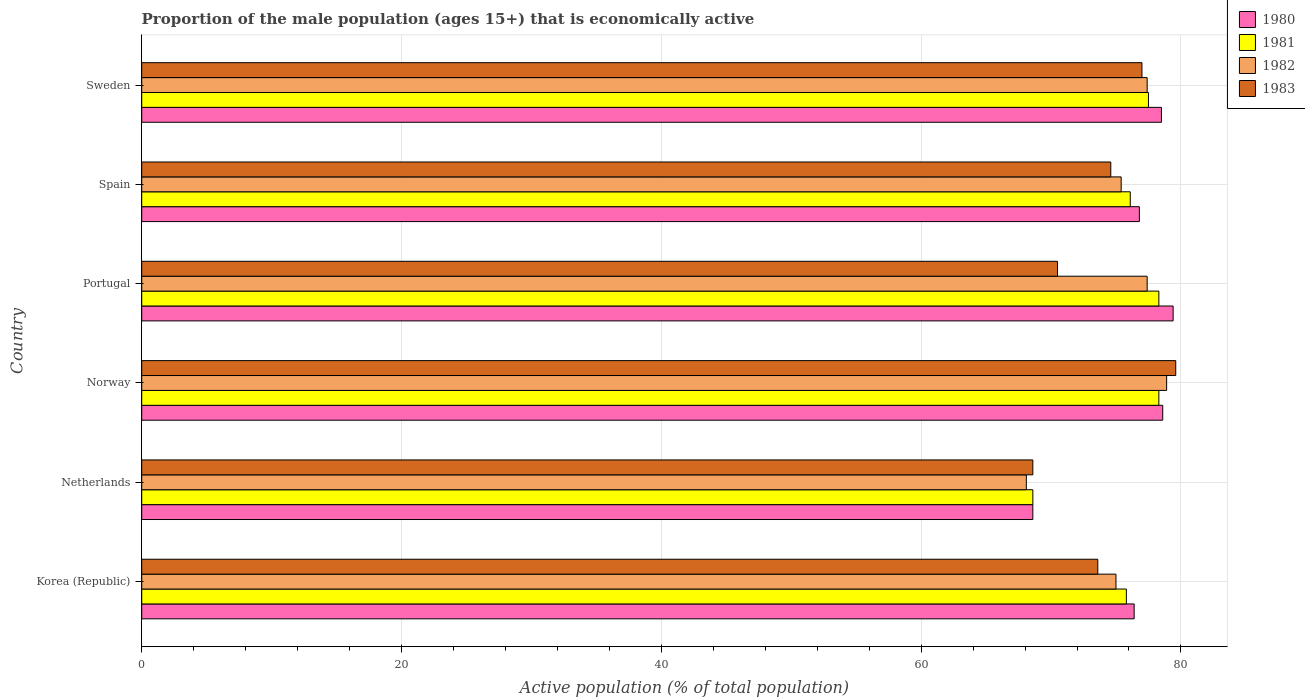Are the number of bars per tick equal to the number of legend labels?
Make the answer very short. Yes. Are the number of bars on each tick of the Y-axis equal?
Offer a terse response. Yes. How many bars are there on the 4th tick from the top?
Give a very brief answer. 4. What is the label of the 4th group of bars from the top?
Your answer should be very brief. Norway. In how many cases, is the number of bars for a given country not equal to the number of legend labels?
Ensure brevity in your answer.  0. What is the proportion of the male population that is economically active in 1981 in Korea (Republic)?
Your answer should be very brief. 75.8. Across all countries, what is the maximum proportion of the male population that is economically active in 1981?
Provide a short and direct response. 78.3. Across all countries, what is the minimum proportion of the male population that is economically active in 1982?
Provide a succinct answer. 68.1. In which country was the proportion of the male population that is economically active in 1983 maximum?
Your response must be concise. Norway. In which country was the proportion of the male population that is economically active in 1981 minimum?
Provide a short and direct response. Netherlands. What is the total proportion of the male population that is economically active in 1983 in the graph?
Your answer should be compact. 443.9. What is the average proportion of the male population that is economically active in 1981 per country?
Your answer should be very brief. 75.77. What is the difference between the proportion of the male population that is economically active in 1980 and proportion of the male population that is economically active in 1983 in Norway?
Give a very brief answer. -1. What is the ratio of the proportion of the male population that is economically active in 1980 in Netherlands to that in Sweden?
Your response must be concise. 0.87. What is the difference between the highest and the second highest proportion of the male population that is economically active in 1982?
Provide a succinct answer. 1.5. What is the difference between the highest and the lowest proportion of the male population that is economically active in 1982?
Ensure brevity in your answer.  10.8. In how many countries, is the proportion of the male population that is economically active in 1981 greater than the average proportion of the male population that is economically active in 1981 taken over all countries?
Give a very brief answer. 5. What does the 3rd bar from the top in Portugal represents?
Your answer should be compact. 1981. How many bars are there?
Provide a short and direct response. 24. How many countries are there in the graph?
Your answer should be compact. 6. What is the difference between two consecutive major ticks on the X-axis?
Your response must be concise. 20. Are the values on the major ticks of X-axis written in scientific E-notation?
Offer a terse response. No. Where does the legend appear in the graph?
Provide a short and direct response. Top right. How many legend labels are there?
Offer a terse response. 4. What is the title of the graph?
Ensure brevity in your answer.  Proportion of the male population (ages 15+) that is economically active. Does "1994" appear as one of the legend labels in the graph?
Make the answer very short. No. What is the label or title of the X-axis?
Ensure brevity in your answer.  Active population (% of total population). What is the Active population (% of total population) in 1980 in Korea (Republic)?
Your answer should be compact. 76.4. What is the Active population (% of total population) in 1981 in Korea (Republic)?
Ensure brevity in your answer.  75.8. What is the Active population (% of total population) in 1982 in Korea (Republic)?
Your answer should be compact. 75. What is the Active population (% of total population) of 1983 in Korea (Republic)?
Provide a succinct answer. 73.6. What is the Active population (% of total population) of 1980 in Netherlands?
Offer a terse response. 68.6. What is the Active population (% of total population) in 1981 in Netherlands?
Provide a succinct answer. 68.6. What is the Active population (% of total population) in 1982 in Netherlands?
Keep it short and to the point. 68.1. What is the Active population (% of total population) of 1983 in Netherlands?
Make the answer very short. 68.6. What is the Active population (% of total population) of 1980 in Norway?
Give a very brief answer. 78.6. What is the Active population (% of total population) of 1981 in Norway?
Ensure brevity in your answer.  78.3. What is the Active population (% of total population) of 1982 in Norway?
Your answer should be compact. 78.9. What is the Active population (% of total population) in 1983 in Norway?
Your answer should be very brief. 79.6. What is the Active population (% of total population) in 1980 in Portugal?
Offer a terse response. 79.4. What is the Active population (% of total population) in 1981 in Portugal?
Your response must be concise. 78.3. What is the Active population (% of total population) of 1982 in Portugal?
Offer a very short reply. 77.4. What is the Active population (% of total population) of 1983 in Portugal?
Keep it short and to the point. 70.5. What is the Active population (% of total population) of 1980 in Spain?
Offer a terse response. 76.8. What is the Active population (% of total population) of 1981 in Spain?
Your answer should be very brief. 76.1. What is the Active population (% of total population) in 1982 in Spain?
Your answer should be compact. 75.4. What is the Active population (% of total population) in 1983 in Spain?
Your response must be concise. 74.6. What is the Active population (% of total population) of 1980 in Sweden?
Your answer should be compact. 78.5. What is the Active population (% of total population) in 1981 in Sweden?
Your answer should be very brief. 77.5. What is the Active population (% of total population) of 1982 in Sweden?
Your response must be concise. 77.4. Across all countries, what is the maximum Active population (% of total population) of 1980?
Provide a short and direct response. 79.4. Across all countries, what is the maximum Active population (% of total population) of 1981?
Provide a short and direct response. 78.3. Across all countries, what is the maximum Active population (% of total population) in 1982?
Offer a very short reply. 78.9. Across all countries, what is the maximum Active population (% of total population) of 1983?
Your answer should be compact. 79.6. Across all countries, what is the minimum Active population (% of total population) of 1980?
Your answer should be very brief. 68.6. Across all countries, what is the minimum Active population (% of total population) in 1981?
Offer a very short reply. 68.6. Across all countries, what is the minimum Active population (% of total population) in 1982?
Offer a very short reply. 68.1. Across all countries, what is the minimum Active population (% of total population) of 1983?
Provide a succinct answer. 68.6. What is the total Active population (% of total population) of 1980 in the graph?
Ensure brevity in your answer.  458.3. What is the total Active population (% of total population) of 1981 in the graph?
Offer a very short reply. 454.6. What is the total Active population (% of total population) of 1982 in the graph?
Offer a very short reply. 452.2. What is the total Active population (% of total population) in 1983 in the graph?
Your answer should be compact. 443.9. What is the difference between the Active population (% of total population) in 1980 in Korea (Republic) and that in Netherlands?
Provide a succinct answer. 7.8. What is the difference between the Active population (% of total population) of 1981 in Korea (Republic) and that in Netherlands?
Offer a very short reply. 7.2. What is the difference between the Active population (% of total population) in 1983 in Korea (Republic) and that in Netherlands?
Ensure brevity in your answer.  5. What is the difference between the Active population (% of total population) in 1980 in Korea (Republic) and that in Norway?
Offer a terse response. -2.2. What is the difference between the Active population (% of total population) of 1981 in Korea (Republic) and that in Norway?
Your answer should be compact. -2.5. What is the difference between the Active population (% of total population) in 1982 in Korea (Republic) and that in Norway?
Ensure brevity in your answer.  -3.9. What is the difference between the Active population (% of total population) of 1980 in Korea (Republic) and that in Spain?
Your response must be concise. -0.4. What is the difference between the Active population (% of total population) of 1981 in Korea (Republic) and that in Spain?
Your response must be concise. -0.3. What is the difference between the Active population (% of total population) of 1983 in Korea (Republic) and that in Spain?
Your answer should be compact. -1. What is the difference between the Active population (% of total population) in 1980 in Korea (Republic) and that in Sweden?
Give a very brief answer. -2.1. What is the difference between the Active population (% of total population) in 1980 in Netherlands and that in Norway?
Your answer should be very brief. -10. What is the difference between the Active population (% of total population) in 1981 in Netherlands and that in Norway?
Make the answer very short. -9.7. What is the difference between the Active population (% of total population) of 1982 in Netherlands and that in Norway?
Provide a succinct answer. -10.8. What is the difference between the Active population (% of total population) in 1983 in Netherlands and that in Norway?
Offer a very short reply. -11. What is the difference between the Active population (% of total population) of 1980 in Netherlands and that in Portugal?
Your response must be concise. -10.8. What is the difference between the Active population (% of total population) in 1981 in Netherlands and that in Portugal?
Provide a succinct answer. -9.7. What is the difference between the Active population (% of total population) of 1980 in Netherlands and that in Spain?
Ensure brevity in your answer.  -8.2. What is the difference between the Active population (% of total population) of 1981 in Netherlands and that in Spain?
Offer a terse response. -7.5. What is the difference between the Active population (% of total population) of 1982 in Netherlands and that in Spain?
Your answer should be compact. -7.3. What is the difference between the Active population (% of total population) of 1980 in Netherlands and that in Sweden?
Give a very brief answer. -9.9. What is the difference between the Active population (% of total population) of 1982 in Netherlands and that in Sweden?
Offer a very short reply. -9.3. What is the difference between the Active population (% of total population) in 1983 in Netherlands and that in Sweden?
Ensure brevity in your answer.  -8.4. What is the difference between the Active population (% of total population) in 1980 in Norway and that in Portugal?
Your answer should be compact. -0.8. What is the difference between the Active population (% of total population) in 1981 in Norway and that in Portugal?
Provide a short and direct response. 0. What is the difference between the Active population (% of total population) in 1982 in Norway and that in Portugal?
Your response must be concise. 1.5. What is the difference between the Active population (% of total population) in 1980 in Norway and that in Spain?
Make the answer very short. 1.8. What is the difference between the Active population (% of total population) in 1981 in Norway and that in Spain?
Keep it short and to the point. 2.2. What is the difference between the Active population (% of total population) of 1982 in Norway and that in Spain?
Your response must be concise. 3.5. What is the difference between the Active population (% of total population) in 1983 in Norway and that in Spain?
Make the answer very short. 5. What is the difference between the Active population (% of total population) in 1982 in Norway and that in Sweden?
Offer a terse response. 1.5. What is the difference between the Active population (% of total population) in 1980 in Portugal and that in Spain?
Your answer should be very brief. 2.6. What is the difference between the Active population (% of total population) of 1982 in Portugal and that in Spain?
Make the answer very short. 2. What is the difference between the Active population (% of total population) in 1981 in Portugal and that in Sweden?
Make the answer very short. 0.8. What is the difference between the Active population (% of total population) in 1982 in Portugal and that in Sweden?
Provide a succinct answer. 0. What is the difference between the Active population (% of total population) in 1983 in Portugal and that in Sweden?
Your answer should be very brief. -6.5. What is the difference between the Active population (% of total population) of 1981 in Spain and that in Sweden?
Your answer should be very brief. -1.4. What is the difference between the Active population (% of total population) in 1982 in Spain and that in Sweden?
Give a very brief answer. -2. What is the difference between the Active population (% of total population) of 1983 in Spain and that in Sweden?
Your answer should be very brief. -2.4. What is the difference between the Active population (% of total population) in 1981 in Korea (Republic) and the Active population (% of total population) in 1982 in Netherlands?
Your answer should be compact. 7.7. What is the difference between the Active population (% of total population) of 1980 in Korea (Republic) and the Active population (% of total population) of 1981 in Norway?
Ensure brevity in your answer.  -1.9. What is the difference between the Active population (% of total population) of 1981 in Korea (Republic) and the Active population (% of total population) of 1982 in Norway?
Provide a short and direct response. -3.1. What is the difference between the Active population (% of total population) in 1981 in Korea (Republic) and the Active population (% of total population) in 1982 in Portugal?
Make the answer very short. -1.6. What is the difference between the Active population (% of total population) in 1980 in Korea (Republic) and the Active population (% of total population) in 1982 in Spain?
Your response must be concise. 1. What is the difference between the Active population (% of total population) in 1982 in Korea (Republic) and the Active population (% of total population) in 1983 in Spain?
Provide a succinct answer. 0.4. What is the difference between the Active population (% of total population) in 1980 in Korea (Republic) and the Active population (% of total population) in 1981 in Sweden?
Your answer should be compact. -1.1. What is the difference between the Active population (% of total population) in 1981 in Korea (Republic) and the Active population (% of total population) in 1982 in Sweden?
Give a very brief answer. -1.6. What is the difference between the Active population (% of total population) in 1981 in Korea (Republic) and the Active population (% of total population) in 1983 in Sweden?
Offer a terse response. -1.2. What is the difference between the Active population (% of total population) of 1980 in Netherlands and the Active population (% of total population) of 1981 in Norway?
Ensure brevity in your answer.  -9.7. What is the difference between the Active population (% of total population) in 1980 in Netherlands and the Active population (% of total population) in 1982 in Norway?
Make the answer very short. -10.3. What is the difference between the Active population (% of total population) of 1980 in Netherlands and the Active population (% of total population) of 1983 in Norway?
Provide a short and direct response. -11. What is the difference between the Active population (% of total population) in 1981 in Netherlands and the Active population (% of total population) in 1983 in Norway?
Keep it short and to the point. -11. What is the difference between the Active population (% of total population) of 1982 in Netherlands and the Active population (% of total population) of 1983 in Norway?
Give a very brief answer. -11.5. What is the difference between the Active population (% of total population) in 1980 in Netherlands and the Active population (% of total population) in 1982 in Portugal?
Offer a very short reply. -8.8. What is the difference between the Active population (% of total population) of 1980 in Netherlands and the Active population (% of total population) of 1983 in Portugal?
Give a very brief answer. -1.9. What is the difference between the Active population (% of total population) of 1982 in Netherlands and the Active population (% of total population) of 1983 in Portugal?
Ensure brevity in your answer.  -2.4. What is the difference between the Active population (% of total population) of 1980 in Netherlands and the Active population (% of total population) of 1982 in Spain?
Provide a short and direct response. -6.8. What is the difference between the Active population (% of total population) in 1981 in Netherlands and the Active population (% of total population) in 1983 in Spain?
Give a very brief answer. -6. What is the difference between the Active population (% of total population) in 1982 in Netherlands and the Active population (% of total population) in 1983 in Spain?
Make the answer very short. -6.5. What is the difference between the Active population (% of total population) of 1981 in Netherlands and the Active population (% of total population) of 1982 in Sweden?
Ensure brevity in your answer.  -8.8. What is the difference between the Active population (% of total population) in 1981 in Netherlands and the Active population (% of total population) in 1983 in Sweden?
Offer a terse response. -8.4. What is the difference between the Active population (% of total population) in 1982 in Norway and the Active population (% of total population) in 1983 in Portugal?
Make the answer very short. 8.4. What is the difference between the Active population (% of total population) in 1980 in Norway and the Active population (% of total population) in 1981 in Spain?
Provide a succinct answer. 2.5. What is the difference between the Active population (% of total population) of 1980 in Norway and the Active population (% of total population) of 1983 in Spain?
Provide a succinct answer. 4. What is the difference between the Active population (% of total population) of 1981 in Norway and the Active population (% of total population) of 1982 in Spain?
Ensure brevity in your answer.  2.9. What is the difference between the Active population (% of total population) in 1981 in Norway and the Active population (% of total population) in 1983 in Sweden?
Ensure brevity in your answer.  1.3. What is the difference between the Active population (% of total population) of 1980 in Portugal and the Active population (% of total population) of 1981 in Spain?
Keep it short and to the point. 3.3. What is the difference between the Active population (% of total population) of 1980 in Portugal and the Active population (% of total population) of 1983 in Spain?
Make the answer very short. 4.8. What is the difference between the Active population (% of total population) in 1981 in Portugal and the Active population (% of total population) in 1982 in Spain?
Provide a short and direct response. 2.9. What is the difference between the Active population (% of total population) in 1981 in Portugal and the Active population (% of total population) in 1983 in Spain?
Keep it short and to the point. 3.7. What is the difference between the Active population (% of total population) of 1982 in Portugal and the Active population (% of total population) of 1983 in Spain?
Ensure brevity in your answer.  2.8. What is the difference between the Active population (% of total population) of 1980 in Portugal and the Active population (% of total population) of 1981 in Sweden?
Keep it short and to the point. 1.9. What is the difference between the Active population (% of total population) of 1980 in Portugal and the Active population (% of total population) of 1982 in Sweden?
Provide a short and direct response. 2. What is the difference between the Active population (% of total population) in 1981 in Spain and the Active population (% of total population) in 1982 in Sweden?
Give a very brief answer. -1.3. What is the difference between the Active population (% of total population) in 1981 in Spain and the Active population (% of total population) in 1983 in Sweden?
Make the answer very short. -0.9. What is the difference between the Active population (% of total population) of 1982 in Spain and the Active population (% of total population) of 1983 in Sweden?
Make the answer very short. -1.6. What is the average Active population (% of total population) of 1980 per country?
Ensure brevity in your answer.  76.38. What is the average Active population (% of total population) of 1981 per country?
Your answer should be compact. 75.77. What is the average Active population (% of total population) in 1982 per country?
Your answer should be very brief. 75.37. What is the average Active population (% of total population) in 1983 per country?
Your response must be concise. 73.98. What is the difference between the Active population (% of total population) of 1980 and Active population (% of total population) of 1981 in Korea (Republic)?
Your answer should be compact. 0.6. What is the difference between the Active population (% of total population) in 1980 and Active population (% of total population) in 1982 in Korea (Republic)?
Your answer should be very brief. 1.4. What is the difference between the Active population (% of total population) in 1980 and Active population (% of total population) in 1983 in Korea (Republic)?
Provide a short and direct response. 2.8. What is the difference between the Active population (% of total population) of 1981 and Active population (% of total population) of 1983 in Korea (Republic)?
Ensure brevity in your answer.  2.2. What is the difference between the Active population (% of total population) of 1980 and Active population (% of total population) of 1981 in Netherlands?
Make the answer very short. 0. What is the difference between the Active population (% of total population) in 1980 and Active population (% of total population) in 1983 in Netherlands?
Ensure brevity in your answer.  0. What is the difference between the Active population (% of total population) of 1981 and Active population (% of total population) of 1983 in Netherlands?
Make the answer very short. 0. What is the difference between the Active population (% of total population) in 1980 and Active population (% of total population) in 1981 in Norway?
Keep it short and to the point. 0.3. What is the difference between the Active population (% of total population) in 1980 and Active population (% of total population) in 1983 in Norway?
Give a very brief answer. -1. What is the difference between the Active population (% of total population) in 1981 and Active population (% of total population) in 1982 in Norway?
Give a very brief answer. -0.6. What is the difference between the Active population (% of total population) of 1982 and Active population (% of total population) of 1983 in Norway?
Ensure brevity in your answer.  -0.7. What is the difference between the Active population (% of total population) of 1980 and Active population (% of total population) of 1982 in Portugal?
Give a very brief answer. 2. What is the difference between the Active population (% of total population) in 1981 and Active population (% of total population) in 1982 in Portugal?
Your answer should be compact. 0.9. What is the difference between the Active population (% of total population) in 1980 and Active population (% of total population) in 1983 in Spain?
Give a very brief answer. 2.2. What is the difference between the Active population (% of total population) in 1981 and Active population (% of total population) in 1982 in Spain?
Provide a short and direct response. 0.7. What is the difference between the Active population (% of total population) of 1982 and Active population (% of total population) of 1983 in Spain?
Provide a succinct answer. 0.8. What is the difference between the Active population (% of total population) in 1980 and Active population (% of total population) in 1981 in Sweden?
Provide a short and direct response. 1. What is the difference between the Active population (% of total population) in 1980 and Active population (% of total population) in 1982 in Sweden?
Give a very brief answer. 1.1. What is the difference between the Active population (% of total population) of 1982 and Active population (% of total population) of 1983 in Sweden?
Provide a short and direct response. 0.4. What is the ratio of the Active population (% of total population) in 1980 in Korea (Republic) to that in Netherlands?
Provide a short and direct response. 1.11. What is the ratio of the Active population (% of total population) in 1981 in Korea (Republic) to that in Netherlands?
Keep it short and to the point. 1.1. What is the ratio of the Active population (% of total population) in 1982 in Korea (Republic) to that in Netherlands?
Provide a succinct answer. 1.1. What is the ratio of the Active population (% of total population) of 1983 in Korea (Republic) to that in Netherlands?
Your answer should be compact. 1.07. What is the ratio of the Active population (% of total population) in 1981 in Korea (Republic) to that in Norway?
Provide a short and direct response. 0.97. What is the ratio of the Active population (% of total population) of 1982 in Korea (Republic) to that in Norway?
Keep it short and to the point. 0.95. What is the ratio of the Active population (% of total population) in 1983 in Korea (Republic) to that in Norway?
Give a very brief answer. 0.92. What is the ratio of the Active population (% of total population) in 1980 in Korea (Republic) to that in Portugal?
Give a very brief answer. 0.96. What is the ratio of the Active population (% of total population) of 1981 in Korea (Republic) to that in Portugal?
Offer a terse response. 0.97. What is the ratio of the Active population (% of total population) in 1982 in Korea (Republic) to that in Portugal?
Keep it short and to the point. 0.97. What is the ratio of the Active population (% of total population) of 1983 in Korea (Republic) to that in Portugal?
Give a very brief answer. 1.04. What is the ratio of the Active population (% of total population) of 1980 in Korea (Republic) to that in Spain?
Keep it short and to the point. 0.99. What is the ratio of the Active population (% of total population) in 1983 in Korea (Republic) to that in Spain?
Your response must be concise. 0.99. What is the ratio of the Active population (% of total population) in 1980 in Korea (Republic) to that in Sweden?
Offer a very short reply. 0.97. What is the ratio of the Active population (% of total population) of 1981 in Korea (Republic) to that in Sweden?
Provide a succinct answer. 0.98. What is the ratio of the Active population (% of total population) in 1983 in Korea (Republic) to that in Sweden?
Your response must be concise. 0.96. What is the ratio of the Active population (% of total population) in 1980 in Netherlands to that in Norway?
Your answer should be very brief. 0.87. What is the ratio of the Active population (% of total population) of 1981 in Netherlands to that in Norway?
Provide a succinct answer. 0.88. What is the ratio of the Active population (% of total population) of 1982 in Netherlands to that in Norway?
Give a very brief answer. 0.86. What is the ratio of the Active population (% of total population) in 1983 in Netherlands to that in Norway?
Your answer should be compact. 0.86. What is the ratio of the Active population (% of total population) of 1980 in Netherlands to that in Portugal?
Give a very brief answer. 0.86. What is the ratio of the Active population (% of total population) in 1981 in Netherlands to that in Portugal?
Provide a succinct answer. 0.88. What is the ratio of the Active population (% of total population) of 1982 in Netherlands to that in Portugal?
Your answer should be very brief. 0.88. What is the ratio of the Active population (% of total population) in 1983 in Netherlands to that in Portugal?
Offer a terse response. 0.97. What is the ratio of the Active population (% of total population) in 1980 in Netherlands to that in Spain?
Keep it short and to the point. 0.89. What is the ratio of the Active population (% of total population) in 1981 in Netherlands to that in Spain?
Provide a succinct answer. 0.9. What is the ratio of the Active population (% of total population) in 1982 in Netherlands to that in Spain?
Ensure brevity in your answer.  0.9. What is the ratio of the Active population (% of total population) in 1983 in Netherlands to that in Spain?
Make the answer very short. 0.92. What is the ratio of the Active population (% of total population) in 1980 in Netherlands to that in Sweden?
Your answer should be compact. 0.87. What is the ratio of the Active population (% of total population) in 1981 in Netherlands to that in Sweden?
Make the answer very short. 0.89. What is the ratio of the Active population (% of total population) of 1982 in Netherlands to that in Sweden?
Provide a succinct answer. 0.88. What is the ratio of the Active population (% of total population) of 1983 in Netherlands to that in Sweden?
Keep it short and to the point. 0.89. What is the ratio of the Active population (% of total population) of 1980 in Norway to that in Portugal?
Ensure brevity in your answer.  0.99. What is the ratio of the Active population (% of total population) in 1981 in Norway to that in Portugal?
Your answer should be very brief. 1. What is the ratio of the Active population (% of total population) of 1982 in Norway to that in Portugal?
Provide a short and direct response. 1.02. What is the ratio of the Active population (% of total population) of 1983 in Norway to that in Portugal?
Your response must be concise. 1.13. What is the ratio of the Active population (% of total population) of 1980 in Norway to that in Spain?
Offer a very short reply. 1.02. What is the ratio of the Active population (% of total population) in 1981 in Norway to that in Spain?
Make the answer very short. 1.03. What is the ratio of the Active population (% of total population) of 1982 in Norway to that in Spain?
Your answer should be compact. 1.05. What is the ratio of the Active population (% of total population) of 1983 in Norway to that in Spain?
Your answer should be compact. 1.07. What is the ratio of the Active population (% of total population) in 1980 in Norway to that in Sweden?
Make the answer very short. 1. What is the ratio of the Active population (% of total population) of 1981 in Norway to that in Sweden?
Your answer should be compact. 1.01. What is the ratio of the Active population (% of total population) in 1982 in Norway to that in Sweden?
Your answer should be very brief. 1.02. What is the ratio of the Active population (% of total population) in 1983 in Norway to that in Sweden?
Ensure brevity in your answer.  1.03. What is the ratio of the Active population (% of total population) of 1980 in Portugal to that in Spain?
Offer a terse response. 1.03. What is the ratio of the Active population (% of total population) in 1981 in Portugal to that in Spain?
Your response must be concise. 1.03. What is the ratio of the Active population (% of total population) of 1982 in Portugal to that in Spain?
Offer a very short reply. 1.03. What is the ratio of the Active population (% of total population) of 1983 in Portugal to that in Spain?
Provide a succinct answer. 0.94. What is the ratio of the Active population (% of total population) of 1980 in Portugal to that in Sweden?
Keep it short and to the point. 1.01. What is the ratio of the Active population (% of total population) of 1981 in Portugal to that in Sweden?
Give a very brief answer. 1.01. What is the ratio of the Active population (% of total population) of 1982 in Portugal to that in Sweden?
Your response must be concise. 1. What is the ratio of the Active population (% of total population) in 1983 in Portugal to that in Sweden?
Provide a short and direct response. 0.92. What is the ratio of the Active population (% of total population) in 1980 in Spain to that in Sweden?
Make the answer very short. 0.98. What is the ratio of the Active population (% of total population) in 1981 in Spain to that in Sweden?
Provide a succinct answer. 0.98. What is the ratio of the Active population (% of total population) in 1982 in Spain to that in Sweden?
Your answer should be compact. 0.97. What is the ratio of the Active population (% of total population) of 1983 in Spain to that in Sweden?
Provide a succinct answer. 0.97. What is the difference between the highest and the second highest Active population (% of total population) in 1981?
Keep it short and to the point. 0. What is the difference between the highest and the second highest Active population (% of total population) in 1983?
Your answer should be very brief. 2.6. What is the difference between the highest and the lowest Active population (% of total population) in 1980?
Give a very brief answer. 10.8. What is the difference between the highest and the lowest Active population (% of total population) of 1981?
Give a very brief answer. 9.7. What is the difference between the highest and the lowest Active population (% of total population) of 1982?
Keep it short and to the point. 10.8. What is the difference between the highest and the lowest Active population (% of total population) of 1983?
Provide a short and direct response. 11. 